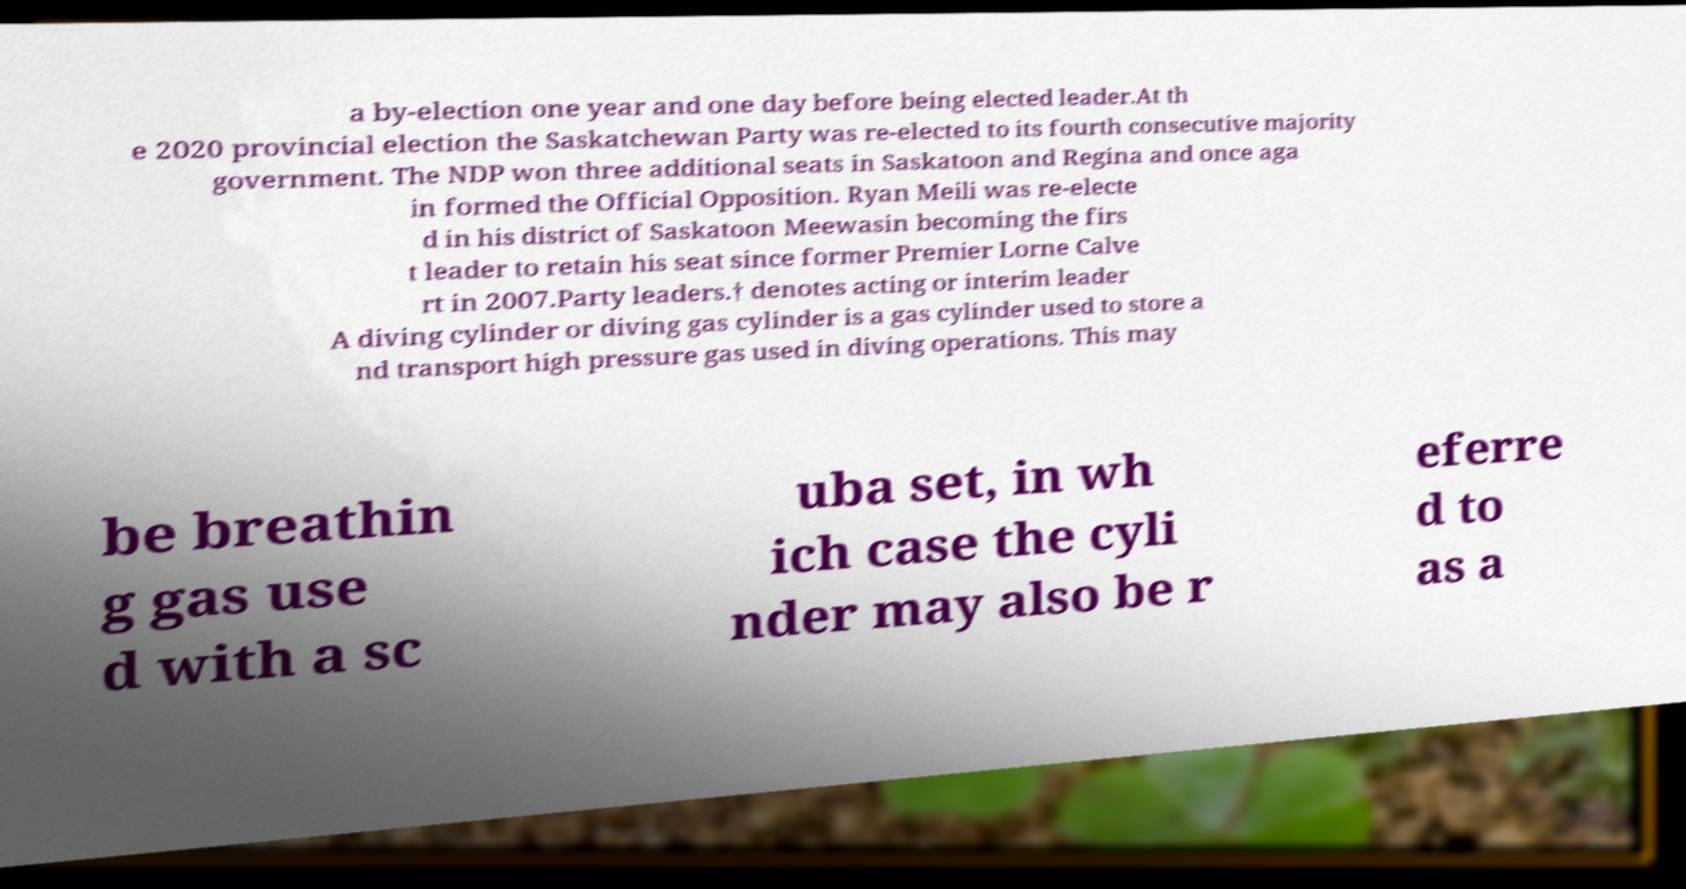For documentation purposes, I need the text within this image transcribed. Could you provide that? a by-election one year and one day before being elected leader.At th e 2020 provincial election the Saskatchewan Party was re-elected to its fourth consecutive majority government. The NDP won three additional seats in Saskatoon and Regina and once aga in formed the Official Opposition. Ryan Meili was re-electe d in his district of Saskatoon Meewasin becoming the firs t leader to retain his seat since former Premier Lorne Calve rt in 2007.Party leaders.† denotes acting or interim leader A diving cylinder or diving gas cylinder is a gas cylinder used to store a nd transport high pressure gas used in diving operations. This may be breathin g gas use d with a sc uba set, in wh ich case the cyli nder may also be r eferre d to as a 